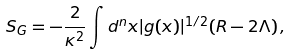Convert formula to latex. <formula><loc_0><loc_0><loc_500><loc_500>S _ { G } = - \frac { 2 } { \kappa ^ { 2 } } \int d ^ { n } x | g ( x ) | ^ { 1 / 2 } ( R - 2 \Lambda ) \, ,</formula> 